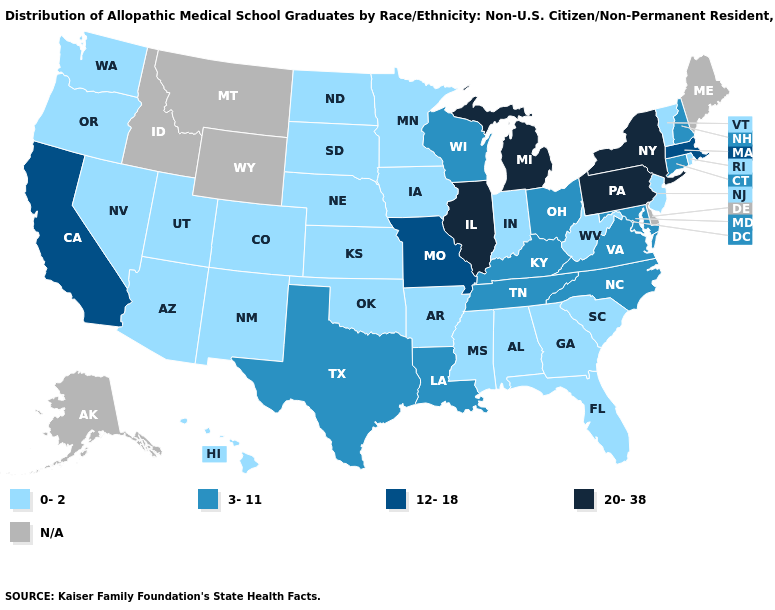Does Pennsylvania have the lowest value in the USA?
Quick response, please. No. What is the lowest value in the USA?
Answer briefly. 0-2. Does the map have missing data?
Short answer required. Yes. What is the value of Kentucky?
Give a very brief answer. 3-11. How many symbols are there in the legend?
Short answer required. 5. What is the highest value in the USA?
Give a very brief answer. 20-38. Name the states that have a value in the range N/A?
Give a very brief answer. Alaska, Delaware, Idaho, Maine, Montana, Wyoming. What is the lowest value in states that border New Mexico?
Write a very short answer. 0-2. Which states have the highest value in the USA?
Quick response, please. Illinois, Michigan, New York, Pennsylvania. Does North Dakota have the highest value in the MidWest?
Write a very short answer. No. Name the states that have a value in the range 12-18?
Write a very short answer. California, Massachusetts, Missouri. What is the value of Louisiana?
Answer briefly. 3-11. What is the highest value in the South ?
Answer briefly. 3-11. 